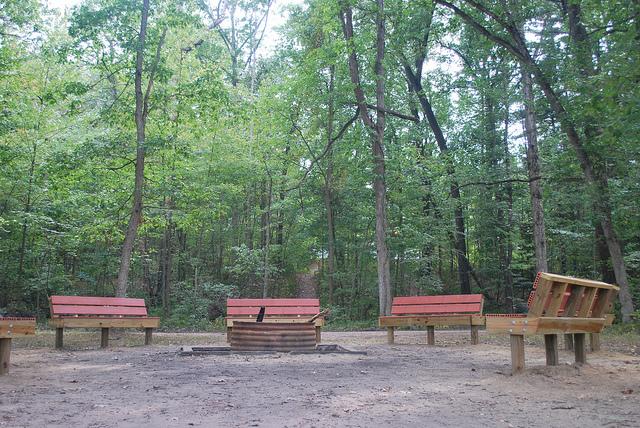Was this photo taken in the woods?
Short answer required. Yes. How many benches are in the park?
Give a very brief answer. 5. How many benches are depicted?
Short answer required. 4. What color is the bench on the left?
Concise answer only. Red. Are the benches painted?
Quick response, please. Yes. Is it dark out?
Short answer required. No. 